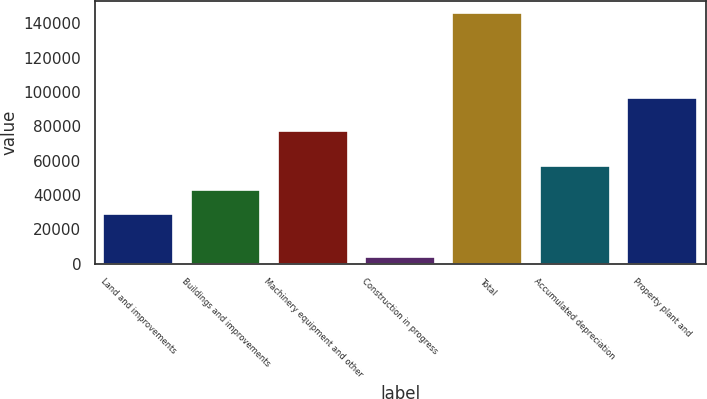Convert chart to OTSL. <chart><loc_0><loc_0><loc_500><loc_500><bar_chart><fcel>Land and improvements<fcel>Buildings and improvements<fcel>Machinery equipment and other<fcel>Construction in progress<fcel>Total<fcel>Accumulated depreciation<fcel>Property plant and<nl><fcel>28715<fcel>42908.3<fcel>77091<fcel>3828<fcel>145761<fcel>57101.6<fcel>96241<nl></chart> 